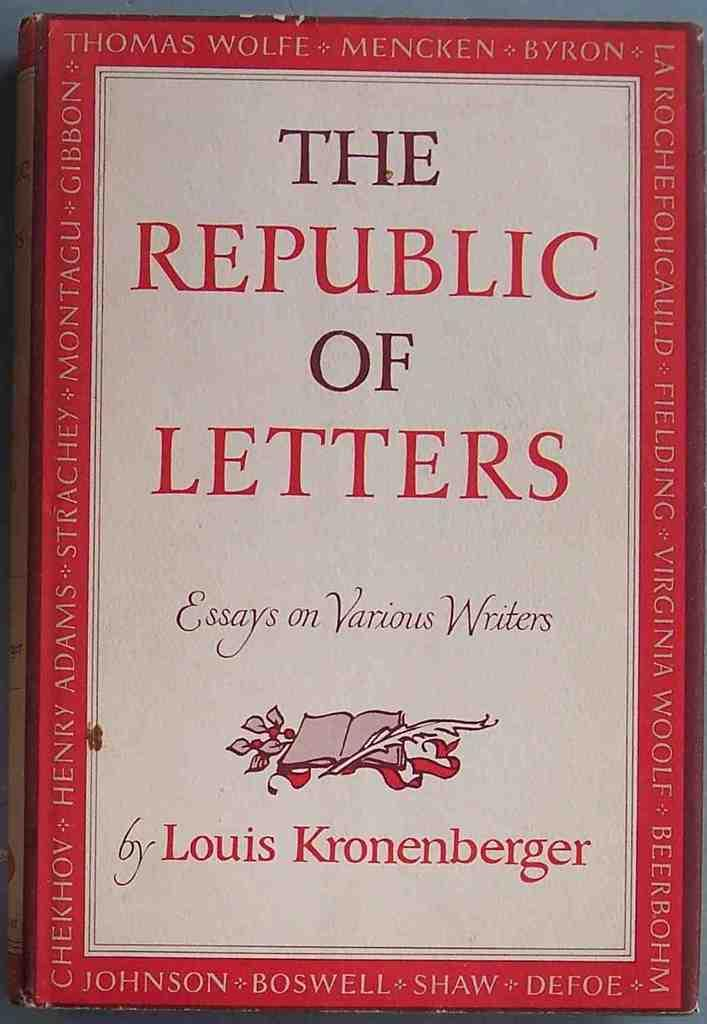<image>
Provide a brief description of the given image. A book of essays on writers has a book on the cover. 